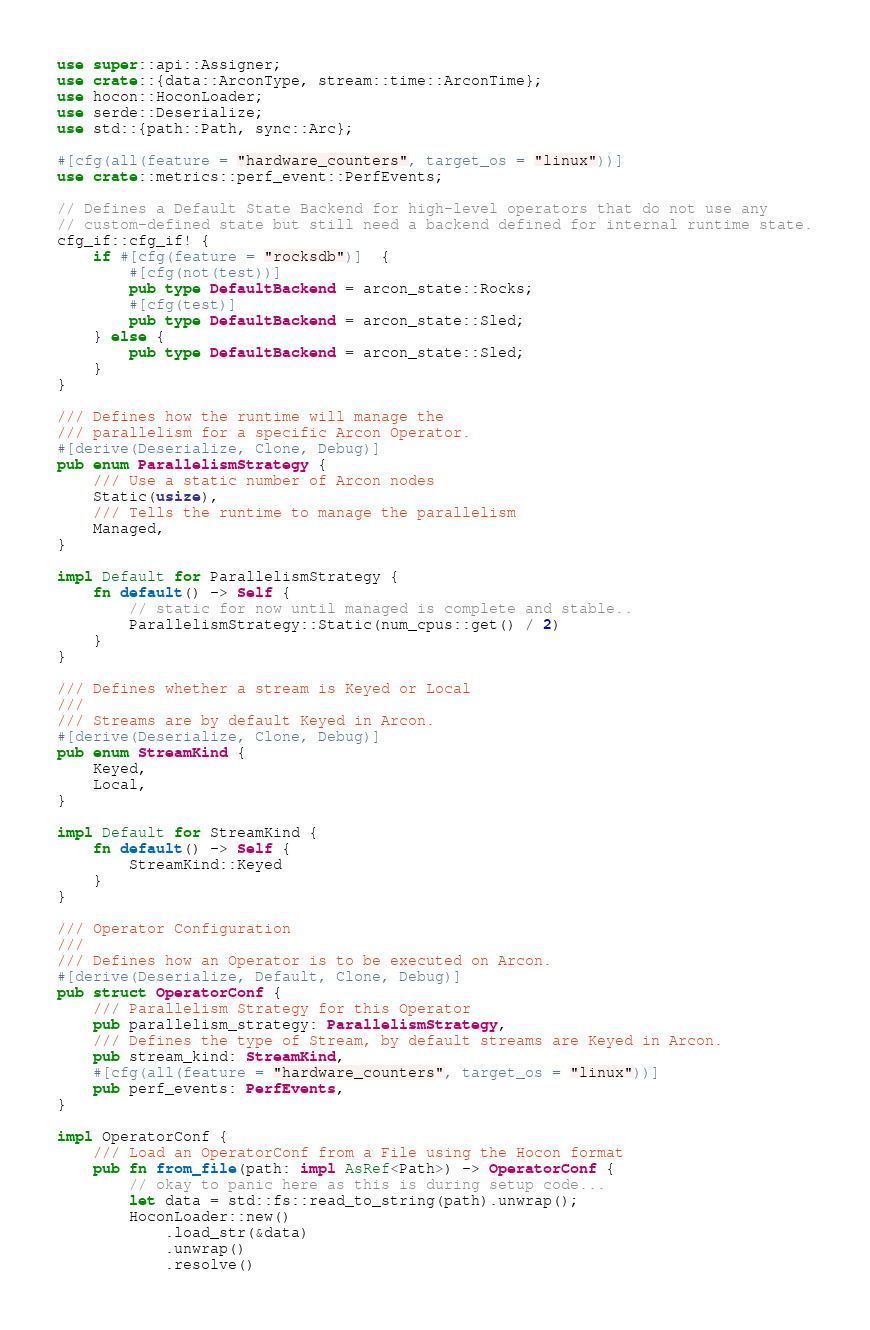Convert code to text. <code><loc_0><loc_0><loc_500><loc_500><_Rust_>use super::api::Assigner;
use crate::{data::ArconType, stream::time::ArconTime};
use hocon::HoconLoader;
use serde::Deserialize;
use std::{path::Path, sync::Arc};

#[cfg(all(feature = "hardware_counters", target_os = "linux"))]
use crate::metrics::perf_event::PerfEvents;

// Defines a Default State Backend for high-level operators that do not use any
// custom-defined state but still need a backend defined for internal runtime state.
cfg_if::cfg_if! {
    if #[cfg(feature = "rocksdb")]  {
        #[cfg(not(test))]
        pub type DefaultBackend = arcon_state::Rocks;
        #[cfg(test)]
        pub type DefaultBackend = arcon_state::Sled;
    } else {
        pub type DefaultBackend = arcon_state::Sled;
    }
}

/// Defines how the runtime will manage the
/// parallelism for a specific Arcon Operator.
#[derive(Deserialize, Clone, Debug)]
pub enum ParallelismStrategy {
    /// Use a static number of Arcon nodes
    Static(usize),
    /// Tells the runtime to manage the parallelism
    Managed,
}

impl Default for ParallelismStrategy {
    fn default() -> Self {
        // static for now until managed is complete and stable..
        ParallelismStrategy::Static(num_cpus::get() / 2)
    }
}

/// Defines whether a stream is Keyed or Local
///
/// Streams are by default Keyed in Arcon.
#[derive(Deserialize, Clone, Debug)]
pub enum StreamKind {
    Keyed,
    Local,
}

impl Default for StreamKind {
    fn default() -> Self {
        StreamKind::Keyed
    }
}

/// Operator Configuration
///
/// Defines how an Operator is to be executed on Arcon.
#[derive(Deserialize, Default, Clone, Debug)]
pub struct OperatorConf {
    /// Parallelism Strategy for this Operator
    pub parallelism_strategy: ParallelismStrategy,
    /// Defines the type of Stream, by default streams are Keyed in Arcon.
    pub stream_kind: StreamKind,
    #[cfg(all(feature = "hardware_counters", target_os = "linux"))]
    pub perf_events: PerfEvents,
}

impl OperatorConf {
    /// Load an OperatorConf from a File using the Hocon format
    pub fn from_file(path: impl AsRef<Path>) -> OperatorConf {
        // okay to panic here as this is during setup code...
        let data = std::fs::read_to_string(path).unwrap();
        HoconLoader::new()
            .load_str(&data)
            .unwrap()
            .resolve()</code> 